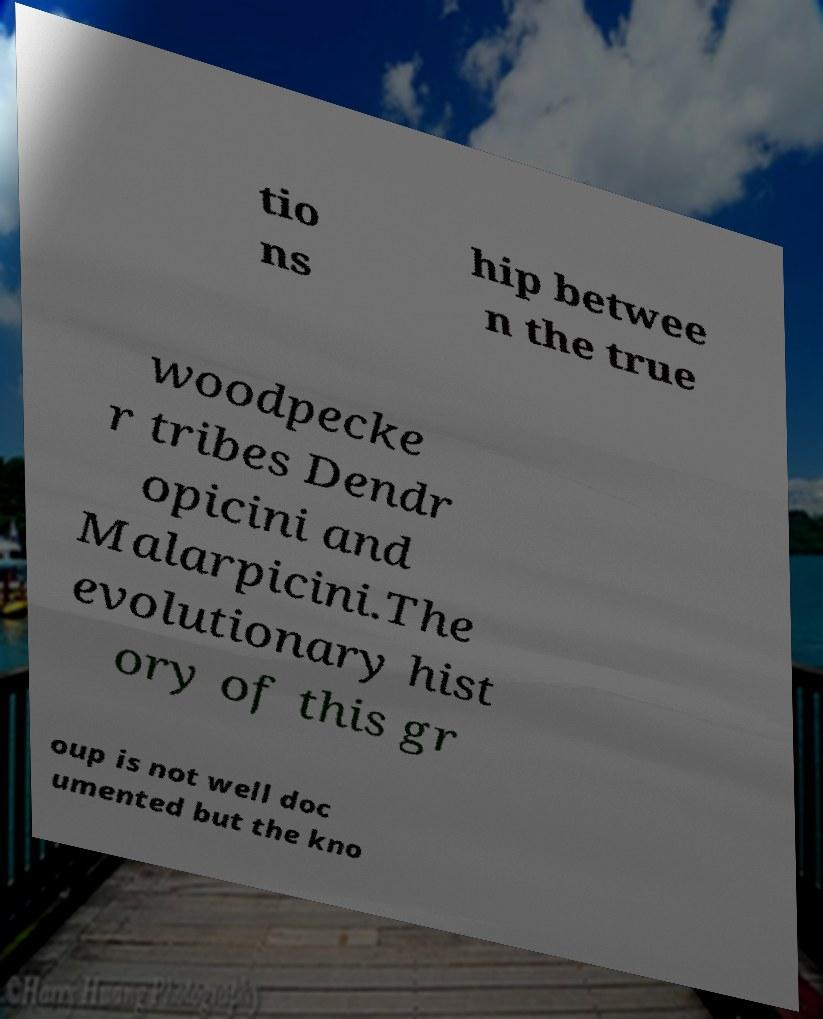Could you extract and type out the text from this image? tio ns hip betwee n the true woodpecke r tribes Dendr opicini and Malarpicini.The evolutionary hist ory of this gr oup is not well doc umented but the kno 